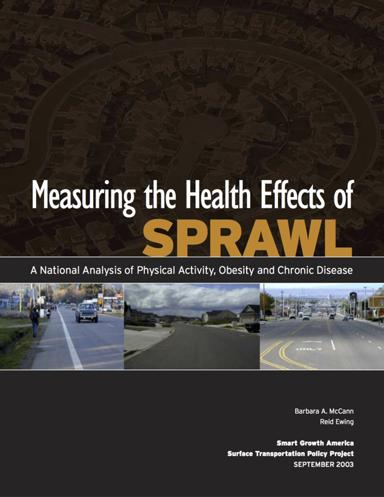What are some key solutions or recommendations offered by the brochure to combat the health effects of sprawl? The brochure recommends enhancing public transportation options, developing more walkable community designs, and implementing policies that encourage physical activity as pivotal strategies to counter the adverse health effects of sprawl. 